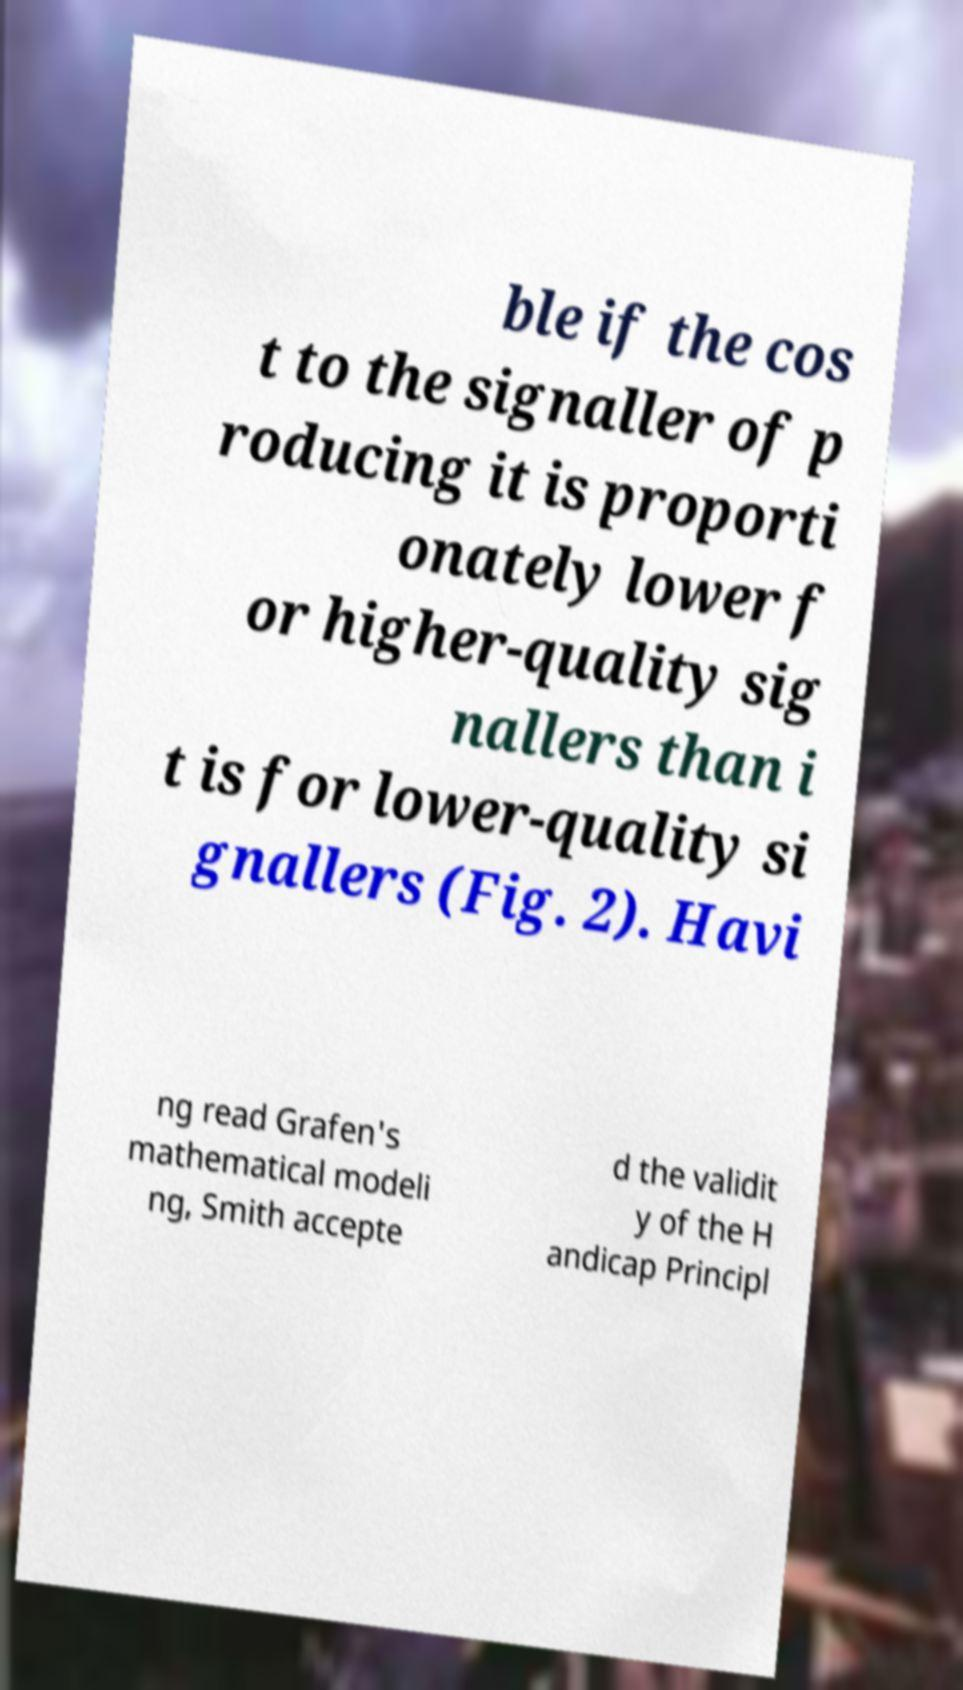What messages or text are displayed in this image? I need them in a readable, typed format. ble if the cos t to the signaller of p roducing it is proporti onately lower f or higher-quality sig nallers than i t is for lower-quality si gnallers (Fig. 2). Havi ng read Grafen's mathematical modeli ng, Smith accepte d the validit y of the H andicap Principl 